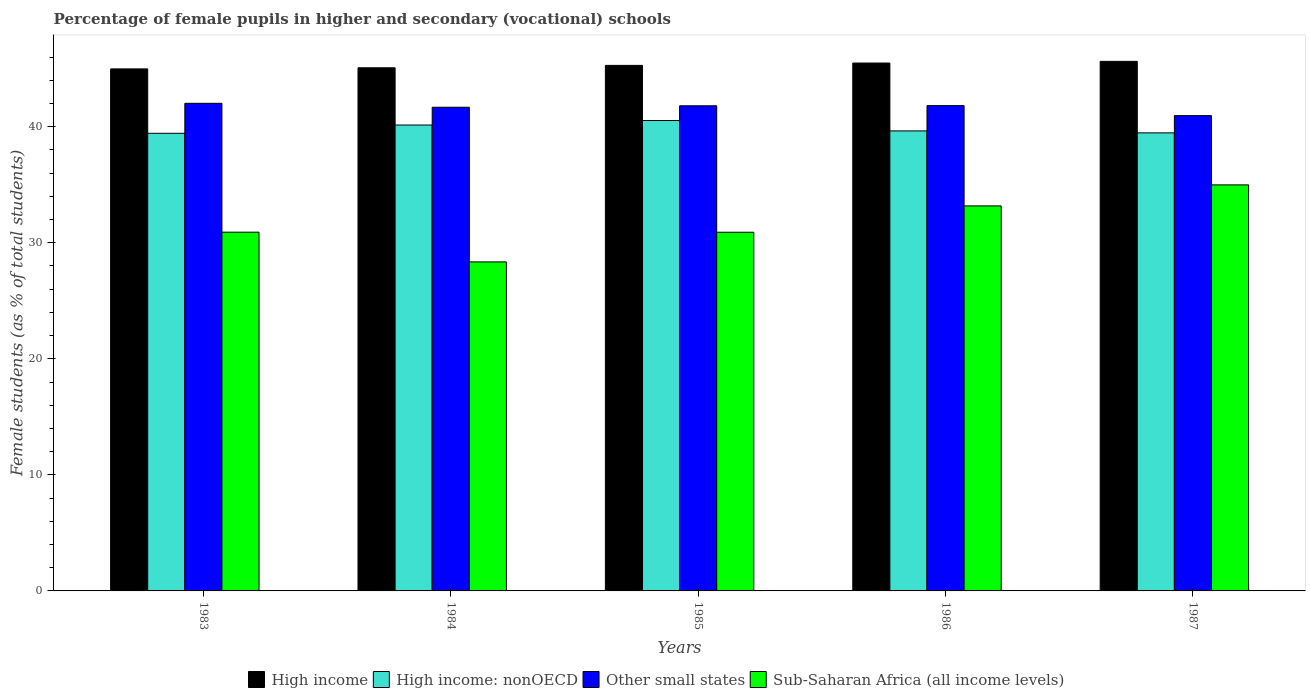How many different coloured bars are there?
Your answer should be compact. 4. How many groups of bars are there?
Provide a succinct answer. 5. How many bars are there on the 3rd tick from the left?
Offer a terse response. 4. How many bars are there on the 2nd tick from the right?
Offer a terse response. 4. In how many cases, is the number of bars for a given year not equal to the number of legend labels?
Offer a terse response. 0. What is the percentage of female pupils in higher and secondary schools in Sub-Saharan Africa (all income levels) in 1983?
Your answer should be compact. 30.91. Across all years, what is the maximum percentage of female pupils in higher and secondary schools in High income?
Provide a short and direct response. 45.63. Across all years, what is the minimum percentage of female pupils in higher and secondary schools in Sub-Saharan Africa (all income levels)?
Your answer should be very brief. 28.35. In which year was the percentage of female pupils in higher and secondary schools in Sub-Saharan Africa (all income levels) minimum?
Keep it short and to the point. 1984. What is the total percentage of female pupils in higher and secondary schools in High income in the graph?
Your answer should be very brief. 226.46. What is the difference between the percentage of female pupils in higher and secondary schools in Other small states in 1983 and that in 1986?
Your answer should be very brief. 0.2. What is the difference between the percentage of female pupils in higher and secondary schools in High income: nonOECD in 1983 and the percentage of female pupils in higher and secondary schools in Other small states in 1984?
Your response must be concise. -2.24. What is the average percentage of female pupils in higher and secondary schools in High income: nonOECD per year?
Your response must be concise. 39.84. In the year 1984, what is the difference between the percentage of female pupils in higher and secondary schools in Other small states and percentage of female pupils in higher and secondary schools in High income?
Provide a succinct answer. -3.4. In how many years, is the percentage of female pupils in higher and secondary schools in High income: nonOECD greater than 8 %?
Offer a very short reply. 5. What is the ratio of the percentage of female pupils in higher and secondary schools in High income in 1983 to that in 1986?
Provide a short and direct response. 0.99. Is the percentage of female pupils in higher and secondary schools in Other small states in 1984 less than that in 1985?
Provide a succinct answer. Yes. What is the difference between the highest and the second highest percentage of female pupils in higher and secondary schools in High income: nonOECD?
Offer a terse response. 0.39. What is the difference between the highest and the lowest percentage of female pupils in higher and secondary schools in Other small states?
Your answer should be compact. 1.06. In how many years, is the percentage of female pupils in higher and secondary schools in Other small states greater than the average percentage of female pupils in higher and secondary schools in Other small states taken over all years?
Keep it short and to the point. 4. Is it the case that in every year, the sum of the percentage of female pupils in higher and secondary schools in Sub-Saharan Africa (all income levels) and percentage of female pupils in higher and secondary schools in High income is greater than the sum of percentage of female pupils in higher and secondary schools in High income: nonOECD and percentage of female pupils in higher and secondary schools in Other small states?
Your response must be concise. No. What does the 3rd bar from the right in 1983 represents?
Give a very brief answer. High income: nonOECD. Is it the case that in every year, the sum of the percentage of female pupils in higher and secondary schools in High income and percentage of female pupils in higher and secondary schools in Other small states is greater than the percentage of female pupils in higher and secondary schools in High income: nonOECD?
Your answer should be compact. Yes. How many bars are there?
Your response must be concise. 20. Are all the bars in the graph horizontal?
Provide a succinct answer. No. How many years are there in the graph?
Your response must be concise. 5. Are the values on the major ticks of Y-axis written in scientific E-notation?
Your response must be concise. No. What is the title of the graph?
Your answer should be compact. Percentage of female pupils in higher and secondary (vocational) schools. Does "Trinidad and Tobago" appear as one of the legend labels in the graph?
Make the answer very short. No. What is the label or title of the Y-axis?
Provide a short and direct response. Female students (as % of total students). What is the Female students (as % of total students) of High income in 1983?
Keep it short and to the point. 44.98. What is the Female students (as % of total students) of High income: nonOECD in 1983?
Ensure brevity in your answer.  39.43. What is the Female students (as % of total students) in Other small states in 1983?
Your answer should be very brief. 42.02. What is the Female students (as % of total students) of Sub-Saharan Africa (all income levels) in 1983?
Offer a very short reply. 30.91. What is the Female students (as % of total students) of High income in 1984?
Provide a short and direct response. 45.08. What is the Female students (as % of total students) of High income: nonOECD in 1984?
Keep it short and to the point. 40.15. What is the Female students (as % of total students) in Other small states in 1984?
Your answer should be very brief. 41.68. What is the Female students (as % of total students) of Sub-Saharan Africa (all income levels) in 1984?
Make the answer very short. 28.35. What is the Female students (as % of total students) in High income in 1985?
Give a very brief answer. 45.28. What is the Female students (as % of total students) in High income: nonOECD in 1985?
Offer a terse response. 40.53. What is the Female students (as % of total students) in Other small states in 1985?
Keep it short and to the point. 41.8. What is the Female students (as % of total students) of Sub-Saharan Africa (all income levels) in 1985?
Provide a short and direct response. 30.91. What is the Female students (as % of total students) of High income in 1986?
Your response must be concise. 45.49. What is the Female students (as % of total students) of High income: nonOECD in 1986?
Make the answer very short. 39.64. What is the Female students (as % of total students) of Other small states in 1986?
Keep it short and to the point. 41.82. What is the Female students (as % of total students) of Sub-Saharan Africa (all income levels) in 1986?
Offer a terse response. 33.18. What is the Female students (as % of total students) of High income in 1987?
Your answer should be very brief. 45.63. What is the Female students (as % of total students) of High income: nonOECD in 1987?
Give a very brief answer. 39.47. What is the Female students (as % of total students) in Other small states in 1987?
Keep it short and to the point. 40.95. What is the Female students (as % of total students) of Sub-Saharan Africa (all income levels) in 1987?
Ensure brevity in your answer.  34.99. Across all years, what is the maximum Female students (as % of total students) of High income?
Provide a succinct answer. 45.63. Across all years, what is the maximum Female students (as % of total students) of High income: nonOECD?
Keep it short and to the point. 40.53. Across all years, what is the maximum Female students (as % of total students) in Other small states?
Your response must be concise. 42.02. Across all years, what is the maximum Female students (as % of total students) of Sub-Saharan Africa (all income levels)?
Keep it short and to the point. 34.99. Across all years, what is the minimum Female students (as % of total students) in High income?
Make the answer very short. 44.98. Across all years, what is the minimum Female students (as % of total students) in High income: nonOECD?
Offer a terse response. 39.43. Across all years, what is the minimum Female students (as % of total students) of Other small states?
Make the answer very short. 40.95. Across all years, what is the minimum Female students (as % of total students) in Sub-Saharan Africa (all income levels)?
Your answer should be very brief. 28.35. What is the total Female students (as % of total students) of High income in the graph?
Offer a terse response. 226.46. What is the total Female students (as % of total students) in High income: nonOECD in the graph?
Offer a very short reply. 199.22. What is the total Female students (as % of total students) of Other small states in the graph?
Keep it short and to the point. 208.27. What is the total Female students (as % of total students) of Sub-Saharan Africa (all income levels) in the graph?
Provide a succinct answer. 158.33. What is the difference between the Female students (as % of total students) of High income in 1983 and that in 1984?
Offer a very short reply. -0.1. What is the difference between the Female students (as % of total students) in High income: nonOECD in 1983 and that in 1984?
Give a very brief answer. -0.71. What is the difference between the Female students (as % of total students) of Other small states in 1983 and that in 1984?
Provide a succinct answer. 0.34. What is the difference between the Female students (as % of total students) of Sub-Saharan Africa (all income levels) in 1983 and that in 1984?
Provide a short and direct response. 2.56. What is the difference between the Female students (as % of total students) of High income in 1983 and that in 1985?
Provide a succinct answer. -0.3. What is the difference between the Female students (as % of total students) in High income: nonOECD in 1983 and that in 1985?
Keep it short and to the point. -1.1. What is the difference between the Female students (as % of total students) in Other small states in 1983 and that in 1985?
Give a very brief answer. 0.21. What is the difference between the Female students (as % of total students) in Sub-Saharan Africa (all income levels) in 1983 and that in 1985?
Provide a succinct answer. 0.01. What is the difference between the Female students (as % of total students) in High income in 1983 and that in 1986?
Ensure brevity in your answer.  -0.51. What is the difference between the Female students (as % of total students) of High income: nonOECD in 1983 and that in 1986?
Keep it short and to the point. -0.2. What is the difference between the Female students (as % of total students) in Other small states in 1983 and that in 1986?
Provide a short and direct response. 0.2. What is the difference between the Female students (as % of total students) of Sub-Saharan Africa (all income levels) in 1983 and that in 1986?
Keep it short and to the point. -2.27. What is the difference between the Female students (as % of total students) in High income in 1983 and that in 1987?
Give a very brief answer. -0.65. What is the difference between the Female students (as % of total students) in High income: nonOECD in 1983 and that in 1987?
Keep it short and to the point. -0.04. What is the difference between the Female students (as % of total students) of Other small states in 1983 and that in 1987?
Your answer should be very brief. 1.06. What is the difference between the Female students (as % of total students) of Sub-Saharan Africa (all income levels) in 1983 and that in 1987?
Your answer should be very brief. -4.08. What is the difference between the Female students (as % of total students) in High income in 1984 and that in 1985?
Make the answer very short. -0.21. What is the difference between the Female students (as % of total students) in High income: nonOECD in 1984 and that in 1985?
Offer a very short reply. -0.39. What is the difference between the Female students (as % of total students) of Other small states in 1984 and that in 1985?
Your response must be concise. -0.13. What is the difference between the Female students (as % of total students) of Sub-Saharan Africa (all income levels) in 1984 and that in 1985?
Your response must be concise. -2.56. What is the difference between the Female students (as % of total students) in High income in 1984 and that in 1986?
Make the answer very short. -0.41. What is the difference between the Female students (as % of total students) in High income: nonOECD in 1984 and that in 1986?
Your response must be concise. 0.51. What is the difference between the Female students (as % of total students) of Other small states in 1984 and that in 1986?
Your answer should be compact. -0.14. What is the difference between the Female students (as % of total students) in Sub-Saharan Africa (all income levels) in 1984 and that in 1986?
Offer a very short reply. -4.83. What is the difference between the Female students (as % of total students) of High income in 1984 and that in 1987?
Your response must be concise. -0.55. What is the difference between the Female students (as % of total students) of High income: nonOECD in 1984 and that in 1987?
Your response must be concise. 0.68. What is the difference between the Female students (as % of total students) in Other small states in 1984 and that in 1987?
Offer a very short reply. 0.72. What is the difference between the Female students (as % of total students) of Sub-Saharan Africa (all income levels) in 1984 and that in 1987?
Give a very brief answer. -6.64. What is the difference between the Female students (as % of total students) in High income in 1985 and that in 1986?
Make the answer very short. -0.2. What is the difference between the Female students (as % of total students) in High income: nonOECD in 1985 and that in 1986?
Provide a succinct answer. 0.9. What is the difference between the Female students (as % of total students) in Other small states in 1985 and that in 1986?
Give a very brief answer. -0.01. What is the difference between the Female students (as % of total students) in Sub-Saharan Africa (all income levels) in 1985 and that in 1986?
Provide a succinct answer. -2.27. What is the difference between the Female students (as % of total students) in High income in 1985 and that in 1987?
Provide a succinct answer. -0.35. What is the difference between the Female students (as % of total students) in High income: nonOECD in 1985 and that in 1987?
Ensure brevity in your answer.  1.06. What is the difference between the Female students (as % of total students) in Other small states in 1985 and that in 1987?
Give a very brief answer. 0.85. What is the difference between the Female students (as % of total students) of Sub-Saharan Africa (all income levels) in 1985 and that in 1987?
Offer a very short reply. -4.08. What is the difference between the Female students (as % of total students) in High income in 1986 and that in 1987?
Your answer should be compact. -0.14. What is the difference between the Female students (as % of total students) of High income: nonOECD in 1986 and that in 1987?
Provide a succinct answer. 0.17. What is the difference between the Female students (as % of total students) of Other small states in 1986 and that in 1987?
Keep it short and to the point. 0.86. What is the difference between the Female students (as % of total students) in Sub-Saharan Africa (all income levels) in 1986 and that in 1987?
Offer a terse response. -1.81. What is the difference between the Female students (as % of total students) of High income in 1983 and the Female students (as % of total students) of High income: nonOECD in 1984?
Give a very brief answer. 4.83. What is the difference between the Female students (as % of total students) of High income in 1983 and the Female students (as % of total students) of Other small states in 1984?
Your answer should be compact. 3.3. What is the difference between the Female students (as % of total students) in High income in 1983 and the Female students (as % of total students) in Sub-Saharan Africa (all income levels) in 1984?
Your answer should be very brief. 16.63. What is the difference between the Female students (as % of total students) of High income: nonOECD in 1983 and the Female students (as % of total students) of Other small states in 1984?
Provide a short and direct response. -2.24. What is the difference between the Female students (as % of total students) of High income: nonOECD in 1983 and the Female students (as % of total students) of Sub-Saharan Africa (all income levels) in 1984?
Offer a very short reply. 11.08. What is the difference between the Female students (as % of total students) of Other small states in 1983 and the Female students (as % of total students) of Sub-Saharan Africa (all income levels) in 1984?
Keep it short and to the point. 13.67. What is the difference between the Female students (as % of total students) in High income in 1983 and the Female students (as % of total students) in High income: nonOECD in 1985?
Provide a succinct answer. 4.45. What is the difference between the Female students (as % of total students) in High income in 1983 and the Female students (as % of total students) in Other small states in 1985?
Your answer should be very brief. 3.18. What is the difference between the Female students (as % of total students) of High income in 1983 and the Female students (as % of total students) of Sub-Saharan Africa (all income levels) in 1985?
Offer a terse response. 14.07. What is the difference between the Female students (as % of total students) in High income: nonOECD in 1983 and the Female students (as % of total students) in Other small states in 1985?
Ensure brevity in your answer.  -2.37. What is the difference between the Female students (as % of total students) of High income: nonOECD in 1983 and the Female students (as % of total students) of Sub-Saharan Africa (all income levels) in 1985?
Provide a short and direct response. 8.53. What is the difference between the Female students (as % of total students) in Other small states in 1983 and the Female students (as % of total students) in Sub-Saharan Africa (all income levels) in 1985?
Your response must be concise. 11.11. What is the difference between the Female students (as % of total students) of High income in 1983 and the Female students (as % of total students) of High income: nonOECD in 1986?
Keep it short and to the point. 5.34. What is the difference between the Female students (as % of total students) in High income in 1983 and the Female students (as % of total students) in Other small states in 1986?
Offer a very short reply. 3.16. What is the difference between the Female students (as % of total students) in High income in 1983 and the Female students (as % of total students) in Sub-Saharan Africa (all income levels) in 1986?
Your answer should be compact. 11.8. What is the difference between the Female students (as % of total students) in High income: nonOECD in 1983 and the Female students (as % of total students) in Other small states in 1986?
Make the answer very short. -2.38. What is the difference between the Female students (as % of total students) in High income: nonOECD in 1983 and the Female students (as % of total students) in Sub-Saharan Africa (all income levels) in 1986?
Provide a succinct answer. 6.26. What is the difference between the Female students (as % of total students) in Other small states in 1983 and the Female students (as % of total students) in Sub-Saharan Africa (all income levels) in 1986?
Keep it short and to the point. 8.84. What is the difference between the Female students (as % of total students) in High income in 1983 and the Female students (as % of total students) in High income: nonOECD in 1987?
Ensure brevity in your answer.  5.51. What is the difference between the Female students (as % of total students) of High income in 1983 and the Female students (as % of total students) of Other small states in 1987?
Offer a terse response. 4.03. What is the difference between the Female students (as % of total students) of High income in 1983 and the Female students (as % of total students) of Sub-Saharan Africa (all income levels) in 1987?
Offer a terse response. 9.99. What is the difference between the Female students (as % of total students) in High income: nonOECD in 1983 and the Female students (as % of total students) in Other small states in 1987?
Your answer should be very brief. -1.52. What is the difference between the Female students (as % of total students) of High income: nonOECD in 1983 and the Female students (as % of total students) of Sub-Saharan Africa (all income levels) in 1987?
Make the answer very short. 4.45. What is the difference between the Female students (as % of total students) in Other small states in 1983 and the Female students (as % of total students) in Sub-Saharan Africa (all income levels) in 1987?
Make the answer very short. 7.03. What is the difference between the Female students (as % of total students) in High income in 1984 and the Female students (as % of total students) in High income: nonOECD in 1985?
Ensure brevity in your answer.  4.54. What is the difference between the Female students (as % of total students) of High income in 1984 and the Female students (as % of total students) of Other small states in 1985?
Keep it short and to the point. 3.27. What is the difference between the Female students (as % of total students) in High income in 1984 and the Female students (as % of total students) in Sub-Saharan Africa (all income levels) in 1985?
Offer a terse response. 14.17. What is the difference between the Female students (as % of total students) in High income: nonOECD in 1984 and the Female students (as % of total students) in Other small states in 1985?
Provide a short and direct response. -1.66. What is the difference between the Female students (as % of total students) of High income: nonOECD in 1984 and the Female students (as % of total students) of Sub-Saharan Africa (all income levels) in 1985?
Ensure brevity in your answer.  9.24. What is the difference between the Female students (as % of total students) in Other small states in 1984 and the Female students (as % of total students) in Sub-Saharan Africa (all income levels) in 1985?
Give a very brief answer. 10.77. What is the difference between the Female students (as % of total students) in High income in 1984 and the Female students (as % of total students) in High income: nonOECD in 1986?
Your answer should be compact. 5.44. What is the difference between the Female students (as % of total students) in High income in 1984 and the Female students (as % of total students) in Other small states in 1986?
Your response must be concise. 3.26. What is the difference between the Female students (as % of total students) in High income in 1984 and the Female students (as % of total students) in Sub-Saharan Africa (all income levels) in 1986?
Your answer should be compact. 11.9. What is the difference between the Female students (as % of total students) of High income: nonOECD in 1984 and the Female students (as % of total students) of Other small states in 1986?
Make the answer very short. -1.67. What is the difference between the Female students (as % of total students) of High income: nonOECD in 1984 and the Female students (as % of total students) of Sub-Saharan Africa (all income levels) in 1986?
Offer a very short reply. 6.97. What is the difference between the Female students (as % of total students) of Other small states in 1984 and the Female students (as % of total students) of Sub-Saharan Africa (all income levels) in 1986?
Your response must be concise. 8.5. What is the difference between the Female students (as % of total students) in High income in 1984 and the Female students (as % of total students) in High income: nonOECD in 1987?
Your answer should be very brief. 5.61. What is the difference between the Female students (as % of total students) of High income in 1984 and the Female students (as % of total students) of Other small states in 1987?
Offer a terse response. 4.12. What is the difference between the Female students (as % of total students) in High income in 1984 and the Female students (as % of total students) in Sub-Saharan Africa (all income levels) in 1987?
Your answer should be compact. 10.09. What is the difference between the Female students (as % of total students) of High income: nonOECD in 1984 and the Female students (as % of total students) of Other small states in 1987?
Your answer should be compact. -0.81. What is the difference between the Female students (as % of total students) of High income: nonOECD in 1984 and the Female students (as % of total students) of Sub-Saharan Africa (all income levels) in 1987?
Provide a short and direct response. 5.16. What is the difference between the Female students (as % of total students) of Other small states in 1984 and the Female students (as % of total students) of Sub-Saharan Africa (all income levels) in 1987?
Give a very brief answer. 6.69. What is the difference between the Female students (as % of total students) in High income in 1985 and the Female students (as % of total students) in High income: nonOECD in 1986?
Provide a succinct answer. 5.65. What is the difference between the Female students (as % of total students) in High income in 1985 and the Female students (as % of total students) in Other small states in 1986?
Provide a succinct answer. 3.47. What is the difference between the Female students (as % of total students) of High income in 1985 and the Female students (as % of total students) of Sub-Saharan Africa (all income levels) in 1986?
Offer a very short reply. 12.11. What is the difference between the Female students (as % of total students) in High income: nonOECD in 1985 and the Female students (as % of total students) in Other small states in 1986?
Ensure brevity in your answer.  -1.28. What is the difference between the Female students (as % of total students) of High income: nonOECD in 1985 and the Female students (as % of total students) of Sub-Saharan Africa (all income levels) in 1986?
Make the answer very short. 7.36. What is the difference between the Female students (as % of total students) in Other small states in 1985 and the Female students (as % of total students) in Sub-Saharan Africa (all income levels) in 1986?
Your response must be concise. 8.63. What is the difference between the Female students (as % of total students) of High income in 1985 and the Female students (as % of total students) of High income: nonOECD in 1987?
Give a very brief answer. 5.82. What is the difference between the Female students (as % of total students) of High income in 1985 and the Female students (as % of total students) of Other small states in 1987?
Provide a succinct answer. 4.33. What is the difference between the Female students (as % of total students) of High income in 1985 and the Female students (as % of total students) of Sub-Saharan Africa (all income levels) in 1987?
Ensure brevity in your answer.  10.3. What is the difference between the Female students (as % of total students) of High income: nonOECD in 1985 and the Female students (as % of total students) of Other small states in 1987?
Keep it short and to the point. -0.42. What is the difference between the Female students (as % of total students) of High income: nonOECD in 1985 and the Female students (as % of total students) of Sub-Saharan Africa (all income levels) in 1987?
Your answer should be very brief. 5.55. What is the difference between the Female students (as % of total students) of Other small states in 1985 and the Female students (as % of total students) of Sub-Saharan Africa (all income levels) in 1987?
Provide a short and direct response. 6.82. What is the difference between the Female students (as % of total students) of High income in 1986 and the Female students (as % of total students) of High income: nonOECD in 1987?
Offer a terse response. 6.02. What is the difference between the Female students (as % of total students) in High income in 1986 and the Female students (as % of total students) in Other small states in 1987?
Offer a very short reply. 4.53. What is the difference between the Female students (as % of total students) in High income in 1986 and the Female students (as % of total students) in Sub-Saharan Africa (all income levels) in 1987?
Your response must be concise. 10.5. What is the difference between the Female students (as % of total students) of High income: nonOECD in 1986 and the Female students (as % of total students) of Other small states in 1987?
Ensure brevity in your answer.  -1.32. What is the difference between the Female students (as % of total students) of High income: nonOECD in 1986 and the Female students (as % of total students) of Sub-Saharan Africa (all income levels) in 1987?
Your response must be concise. 4.65. What is the difference between the Female students (as % of total students) in Other small states in 1986 and the Female students (as % of total students) in Sub-Saharan Africa (all income levels) in 1987?
Provide a succinct answer. 6.83. What is the average Female students (as % of total students) in High income per year?
Provide a short and direct response. 45.29. What is the average Female students (as % of total students) in High income: nonOECD per year?
Your answer should be compact. 39.84. What is the average Female students (as % of total students) in Other small states per year?
Ensure brevity in your answer.  41.65. What is the average Female students (as % of total students) in Sub-Saharan Africa (all income levels) per year?
Ensure brevity in your answer.  31.67. In the year 1983, what is the difference between the Female students (as % of total students) of High income and Female students (as % of total students) of High income: nonOECD?
Your answer should be compact. 5.55. In the year 1983, what is the difference between the Female students (as % of total students) in High income and Female students (as % of total students) in Other small states?
Your answer should be very brief. 2.96. In the year 1983, what is the difference between the Female students (as % of total students) of High income and Female students (as % of total students) of Sub-Saharan Africa (all income levels)?
Your answer should be compact. 14.07. In the year 1983, what is the difference between the Female students (as % of total students) of High income: nonOECD and Female students (as % of total students) of Other small states?
Provide a short and direct response. -2.58. In the year 1983, what is the difference between the Female students (as % of total students) of High income: nonOECD and Female students (as % of total students) of Sub-Saharan Africa (all income levels)?
Provide a succinct answer. 8.52. In the year 1983, what is the difference between the Female students (as % of total students) of Other small states and Female students (as % of total students) of Sub-Saharan Africa (all income levels)?
Make the answer very short. 11.1. In the year 1984, what is the difference between the Female students (as % of total students) in High income and Female students (as % of total students) in High income: nonOECD?
Provide a succinct answer. 4.93. In the year 1984, what is the difference between the Female students (as % of total students) in High income and Female students (as % of total students) in Other small states?
Your answer should be compact. 3.4. In the year 1984, what is the difference between the Female students (as % of total students) in High income and Female students (as % of total students) in Sub-Saharan Africa (all income levels)?
Provide a short and direct response. 16.73. In the year 1984, what is the difference between the Female students (as % of total students) in High income: nonOECD and Female students (as % of total students) in Other small states?
Your answer should be compact. -1.53. In the year 1984, what is the difference between the Female students (as % of total students) in High income: nonOECD and Female students (as % of total students) in Sub-Saharan Africa (all income levels)?
Keep it short and to the point. 11.79. In the year 1984, what is the difference between the Female students (as % of total students) of Other small states and Female students (as % of total students) of Sub-Saharan Africa (all income levels)?
Give a very brief answer. 13.33. In the year 1985, what is the difference between the Female students (as % of total students) of High income and Female students (as % of total students) of High income: nonOECD?
Offer a terse response. 4.75. In the year 1985, what is the difference between the Female students (as % of total students) in High income and Female students (as % of total students) in Other small states?
Keep it short and to the point. 3.48. In the year 1985, what is the difference between the Female students (as % of total students) in High income and Female students (as % of total students) in Sub-Saharan Africa (all income levels)?
Keep it short and to the point. 14.38. In the year 1985, what is the difference between the Female students (as % of total students) of High income: nonOECD and Female students (as % of total students) of Other small states?
Your response must be concise. -1.27. In the year 1985, what is the difference between the Female students (as % of total students) in High income: nonOECD and Female students (as % of total students) in Sub-Saharan Africa (all income levels)?
Make the answer very short. 9.63. In the year 1985, what is the difference between the Female students (as % of total students) of Other small states and Female students (as % of total students) of Sub-Saharan Africa (all income levels)?
Your answer should be very brief. 10.9. In the year 1986, what is the difference between the Female students (as % of total students) in High income and Female students (as % of total students) in High income: nonOECD?
Provide a short and direct response. 5.85. In the year 1986, what is the difference between the Female students (as % of total students) of High income and Female students (as % of total students) of Other small states?
Offer a terse response. 3.67. In the year 1986, what is the difference between the Female students (as % of total students) of High income and Female students (as % of total students) of Sub-Saharan Africa (all income levels)?
Your answer should be compact. 12.31. In the year 1986, what is the difference between the Female students (as % of total students) in High income: nonOECD and Female students (as % of total students) in Other small states?
Ensure brevity in your answer.  -2.18. In the year 1986, what is the difference between the Female students (as % of total students) of High income: nonOECD and Female students (as % of total students) of Sub-Saharan Africa (all income levels)?
Ensure brevity in your answer.  6.46. In the year 1986, what is the difference between the Female students (as % of total students) in Other small states and Female students (as % of total students) in Sub-Saharan Africa (all income levels)?
Offer a terse response. 8.64. In the year 1987, what is the difference between the Female students (as % of total students) of High income and Female students (as % of total students) of High income: nonOECD?
Keep it short and to the point. 6.16. In the year 1987, what is the difference between the Female students (as % of total students) in High income and Female students (as % of total students) in Other small states?
Provide a succinct answer. 4.68. In the year 1987, what is the difference between the Female students (as % of total students) in High income and Female students (as % of total students) in Sub-Saharan Africa (all income levels)?
Your answer should be compact. 10.64. In the year 1987, what is the difference between the Female students (as % of total students) of High income: nonOECD and Female students (as % of total students) of Other small states?
Keep it short and to the point. -1.49. In the year 1987, what is the difference between the Female students (as % of total students) in High income: nonOECD and Female students (as % of total students) in Sub-Saharan Africa (all income levels)?
Make the answer very short. 4.48. In the year 1987, what is the difference between the Female students (as % of total students) in Other small states and Female students (as % of total students) in Sub-Saharan Africa (all income levels)?
Your answer should be compact. 5.97. What is the ratio of the Female students (as % of total students) of High income: nonOECD in 1983 to that in 1984?
Provide a succinct answer. 0.98. What is the ratio of the Female students (as % of total students) of Other small states in 1983 to that in 1984?
Provide a succinct answer. 1.01. What is the ratio of the Female students (as % of total students) of Sub-Saharan Africa (all income levels) in 1983 to that in 1984?
Offer a very short reply. 1.09. What is the ratio of the Female students (as % of total students) of High income: nonOECD in 1983 to that in 1985?
Provide a short and direct response. 0.97. What is the ratio of the Female students (as % of total students) of Other small states in 1983 to that in 1985?
Ensure brevity in your answer.  1.01. What is the ratio of the Female students (as % of total students) of High income in 1983 to that in 1986?
Your response must be concise. 0.99. What is the ratio of the Female students (as % of total students) of High income: nonOECD in 1983 to that in 1986?
Your answer should be compact. 0.99. What is the ratio of the Female students (as % of total students) in Other small states in 1983 to that in 1986?
Make the answer very short. 1. What is the ratio of the Female students (as % of total students) in Sub-Saharan Africa (all income levels) in 1983 to that in 1986?
Ensure brevity in your answer.  0.93. What is the ratio of the Female students (as % of total students) in High income in 1983 to that in 1987?
Offer a terse response. 0.99. What is the ratio of the Female students (as % of total students) of Other small states in 1983 to that in 1987?
Make the answer very short. 1.03. What is the ratio of the Female students (as % of total students) of Sub-Saharan Africa (all income levels) in 1983 to that in 1987?
Ensure brevity in your answer.  0.88. What is the ratio of the Female students (as % of total students) of Other small states in 1984 to that in 1985?
Your answer should be very brief. 1. What is the ratio of the Female students (as % of total students) of Sub-Saharan Africa (all income levels) in 1984 to that in 1985?
Offer a very short reply. 0.92. What is the ratio of the Female students (as % of total students) of High income in 1984 to that in 1986?
Make the answer very short. 0.99. What is the ratio of the Female students (as % of total students) of High income: nonOECD in 1984 to that in 1986?
Keep it short and to the point. 1.01. What is the ratio of the Female students (as % of total students) of Other small states in 1984 to that in 1986?
Offer a very short reply. 1. What is the ratio of the Female students (as % of total students) in Sub-Saharan Africa (all income levels) in 1984 to that in 1986?
Your answer should be compact. 0.85. What is the ratio of the Female students (as % of total students) in High income in 1984 to that in 1987?
Provide a succinct answer. 0.99. What is the ratio of the Female students (as % of total students) in High income: nonOECD in 1984 to that in 1987?
Your response must be concise. 1.02. What is the ratio of the Female students (as % of total students) in Other small states in 1984 to that in 1987?
Your answer should be compact. 1.02. What is the ratio of the Female students (as % of total students) in Sub-Saharan Africa (all income levels) in 1984 to that in 1987?
Your answer should be very brief. 0.81. What is the ratio of the Female students (as % of total students) in High income in 1985 to that in 1986?
Provide a succinct answer. 1. What is the ratio of the Female students (as % of total students) in High income: nonOECD in 1985 to that in 1986?
Give a very brief answer. 1.02. What is the ratio of the Female students (as % of total students) in Other small states in 1985 to that in 1986?
Keep it short and to the point. 1. What is the ratio of the Female students (as % of total students) of Sub-Saharan Africa (all income levels) in 1985 to that in 1986?
Give a very brief answer. 0.93. What is the ratio of the Female students (as % of total students) in High income in 1985 to that in 1987?
Your answer should be compact. 0.99. What is the ratio of the Female students (as % of total students) of Other small states in 1985 to that in 1987?
Your response must be concise. 1.02. What is the ratio of the Female students (as % of total students) in Sub-Saharan Africa (all income levels) in 1985 to that in 1987?
Your answer should be very brief. 0.88. What is the ratio of the Female students (as % of total students) in Other small states in 1986 to that in 1987?
Provide a short and direct response. 1.02. What is the ratio of the Female students (as % of total students) of Sub-Saharan Africa (all income levels) in 1986 to that in 1987?
Your answer should be compact. 0.95. What is the difference between the highest and the second highest Female students (as % of total students) in High income?
Your response must be concise. 0.14. What is the difference between the highest and the second highest Female students (as % of total students) of High income: nonOECD?
Offer a terse response. 0.39. What is the difference between the highest and the second highest Female students (as % of total students) of Other small states?
Make the answer very short. 0.2. What is the difference between the highest and the second highest Female students (as % of total students) of Sub-Saharan Africa (all income levels)?
Give a very brief answer. 1.81. What is the difference between the highest and the lowest Female students (as % of total students) of High income?
Your response must be concise. 0.65. What is the difference between the highest and the lowest Female students (as % of total students) in High income: nonOECD?
Keep it short and to the point. 1.1. What is the difference between the highest and the lowest Female students (as % of total students) in Other small states?
Keep it short and to the point. 1.06. What is the difference between the highest and the lowest Female students (as % of total students) of Sub-Saharan Africa (all income levels)?
Your answer should be compact. 6.64. 